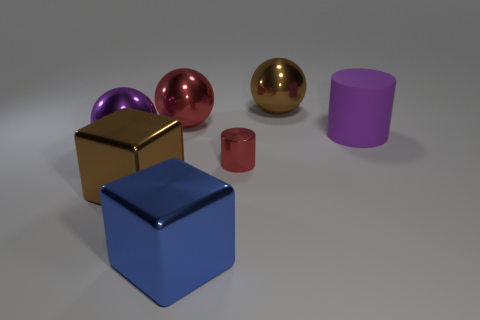The big matte object that is the same shape as the tiny red thing is what color?
Make the answer very short. Purple. Are there any other things that are the same shape as the tiny red thing?
Make the answer very short. Yes. There is a cylinder in front of the purple rubber object; does it have the same color as the large rubber cylinder?
Your answer should be very brief. No. What is the size of the other matte object that is the same shape as the tiny red thing?
Provide a short and direct response. Large. How many small red things are the same material as the purple cylinder?
Provide a succinct answer. 0. Are there any purple shiny spheres behind the thing that is right of the big ball right of the small thing?
Ensure brevity in your answer.  No. What is the shape of the big rubber object?
Ensure brevity in your answer.  Cylinder. Are the red thing in front of the big purple ball and the ball that is right of the blue block made of the same material?
Your response must be concise. Yes. What number of shiny objects have the same color as the big matte thing?
Ensure brevity in your answer.  1. The metallic thing that is both to the left of the red cylinder and behind the purple sphere has what shape?
Offer a terse response. Sphere. 